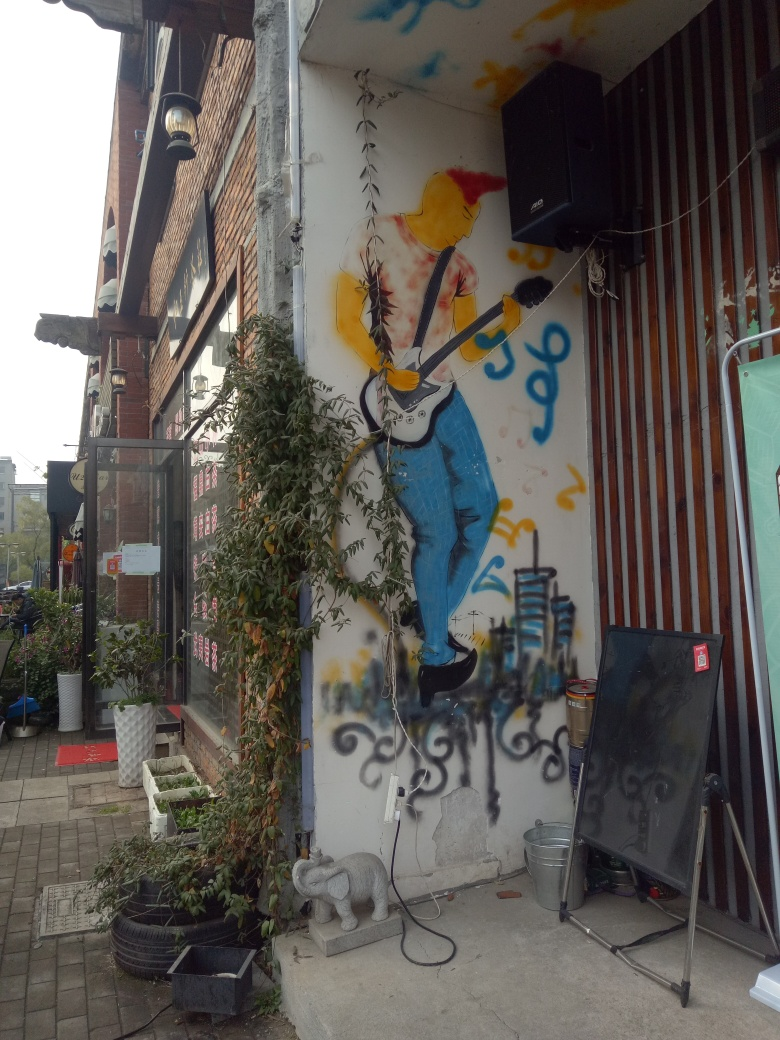Could you provide some insight into the style or influences of the street art depicted? The street art shown injects a vibrant, urban vibe into the scene, featuring a figure in a dynamic pose, which could suggest inspiration from contemporary graffiti art movement known for its bold colors and lifelike portrayals. Personal influences could range from pop culture to abstract expressionism, evidenced by the expressive, somewhat abstract use of color and form. What do you think the artist is trying to convey through this mural? The artist seems to convey a sense of energy and perhaps musical expression—the figure is depicted with a guitar, implying a connection to music. The upward pose and splash of colors may symbolize freedom, creativity, or the exhilarating experience of a live performance. 